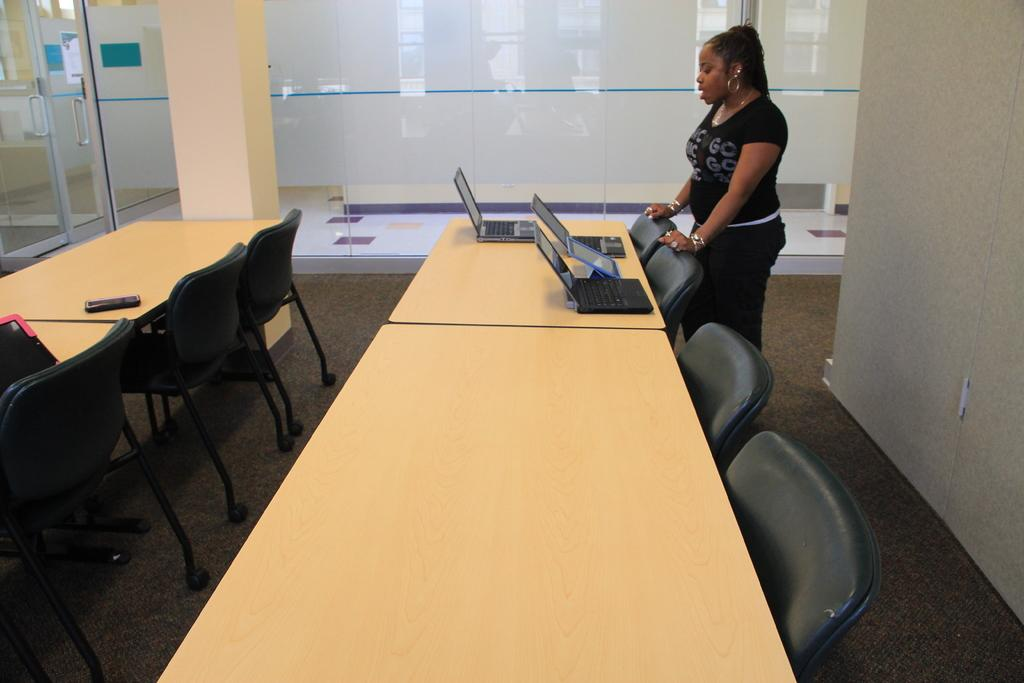Who is standing on the right side of the image? There is a woman standing on the right side of the image. What is located in the center of the image? There is a table in the image. What electronic devices are on the table? Laptops are present on the table. What type of furniture is in the image for sitting? There are chairs in the image. What can be seen in the background of the image? There is a door in the image, which leads to a room. How does the woman burn the laptops in the image? There is no indication in the image that the woman is burning the laptops; they are simply present on the table. 